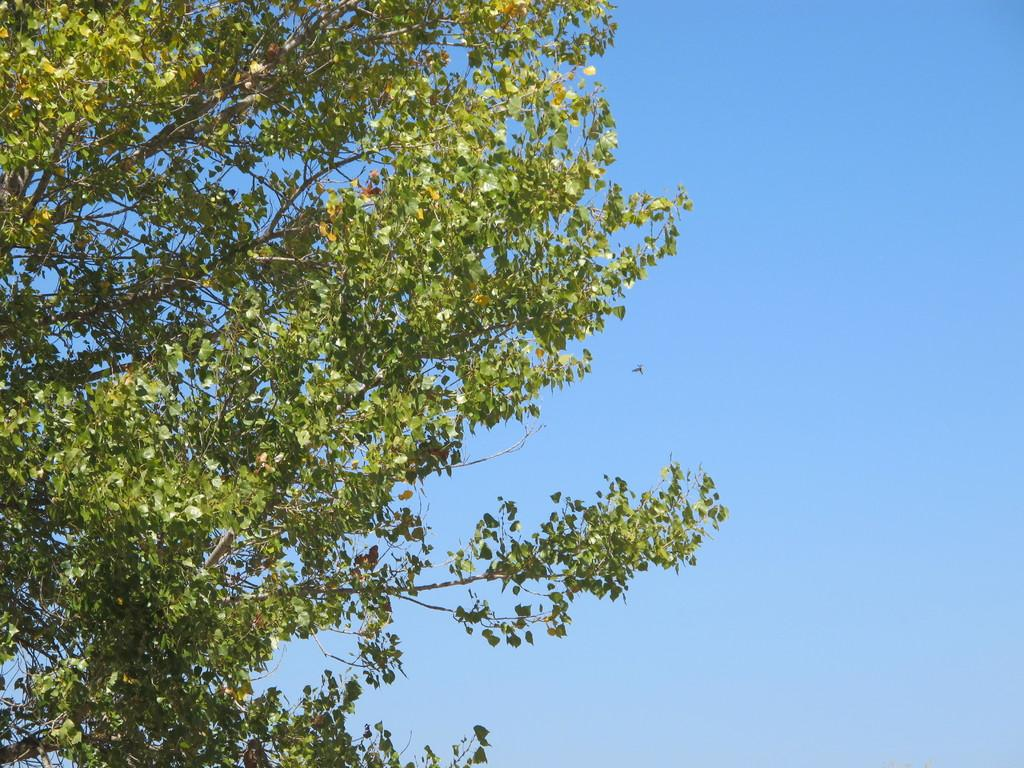What is the main subject of the picture? The main subject of the picture is a tree. What can be observed about the tree's leaves? The tree has green-colored leaves. What is visible in the background of the image? The sky is visible in the background of the image. What type of coil can be seen wrapped around the tree in the image? There is no coil present in the image; it features a tree with green leaves and a visible sky in the background. What kind of toy is hanging from the tree in the image? There is no toy present in the image; it features a tree with green leaves and a visible sky in the background. 